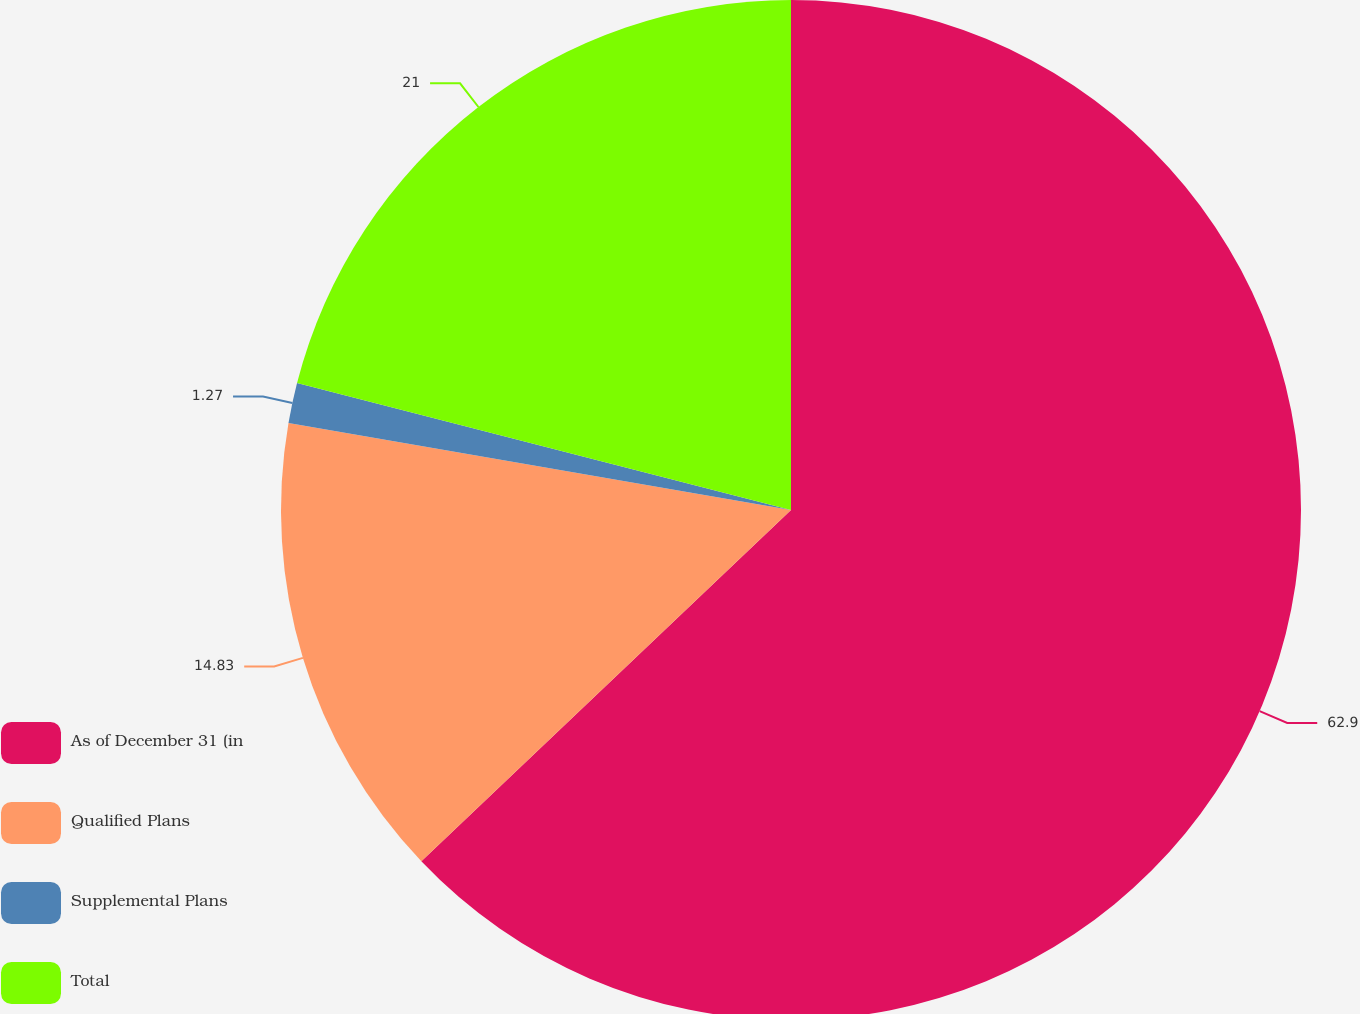Convert chart to OTSL. <chart><loc_0><loc_0><loc_500><loc_500><pie_chart><fcel>As of December 31 (in<fcel>Qualified Plans<fcel>Supplemental Plans<fcel>Total<nl><fcel>62.91%<fcel>14.83%<fcel>1.27%<fcel>21.0%<nl></chart> 